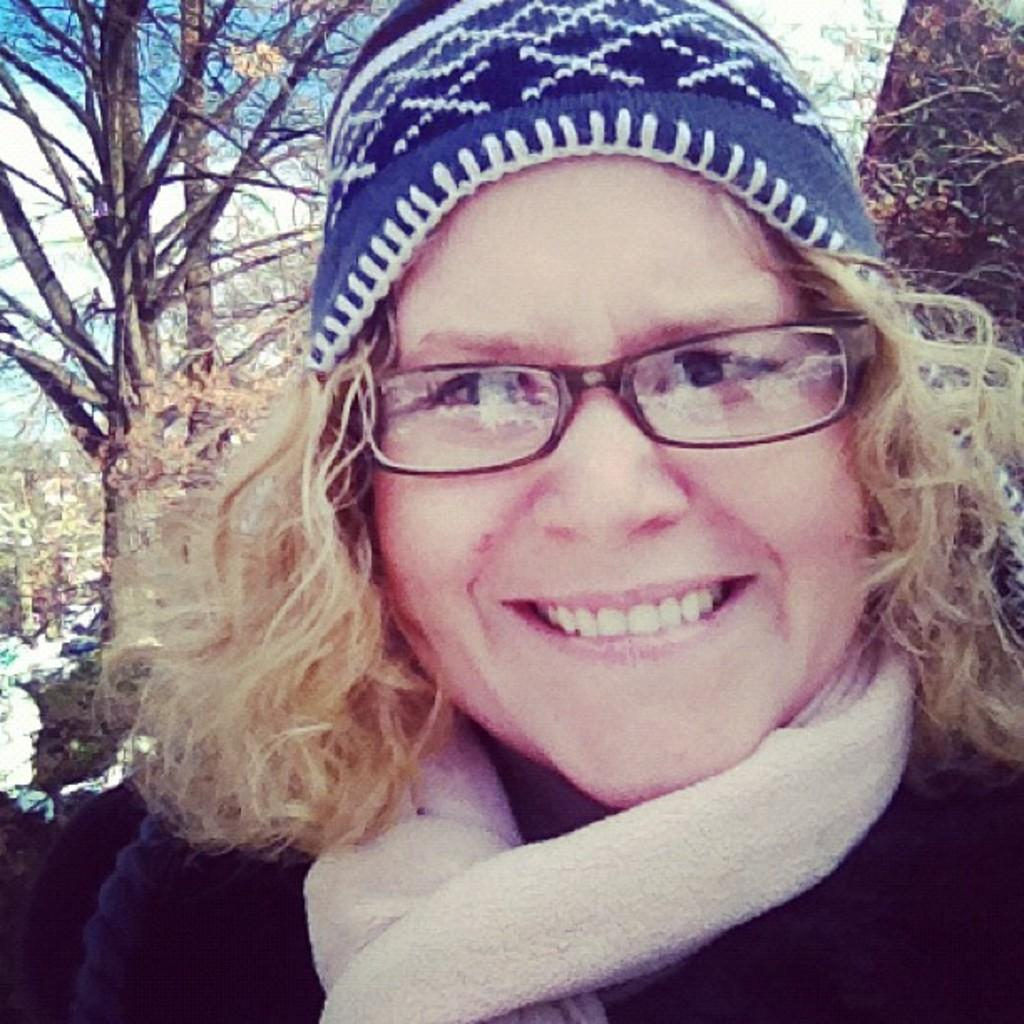Who is the main subject in the image? There is a lady in the image. What accessories is the lady wearing? The lady is wearing glasses, a cap, and a scarf. What can be seen in the background of the image? There are trees in the background of the image. What is the name of the liquid that the lady is holding in the image? There is no liquid visible in the image, and therefore no such item can be identified. 